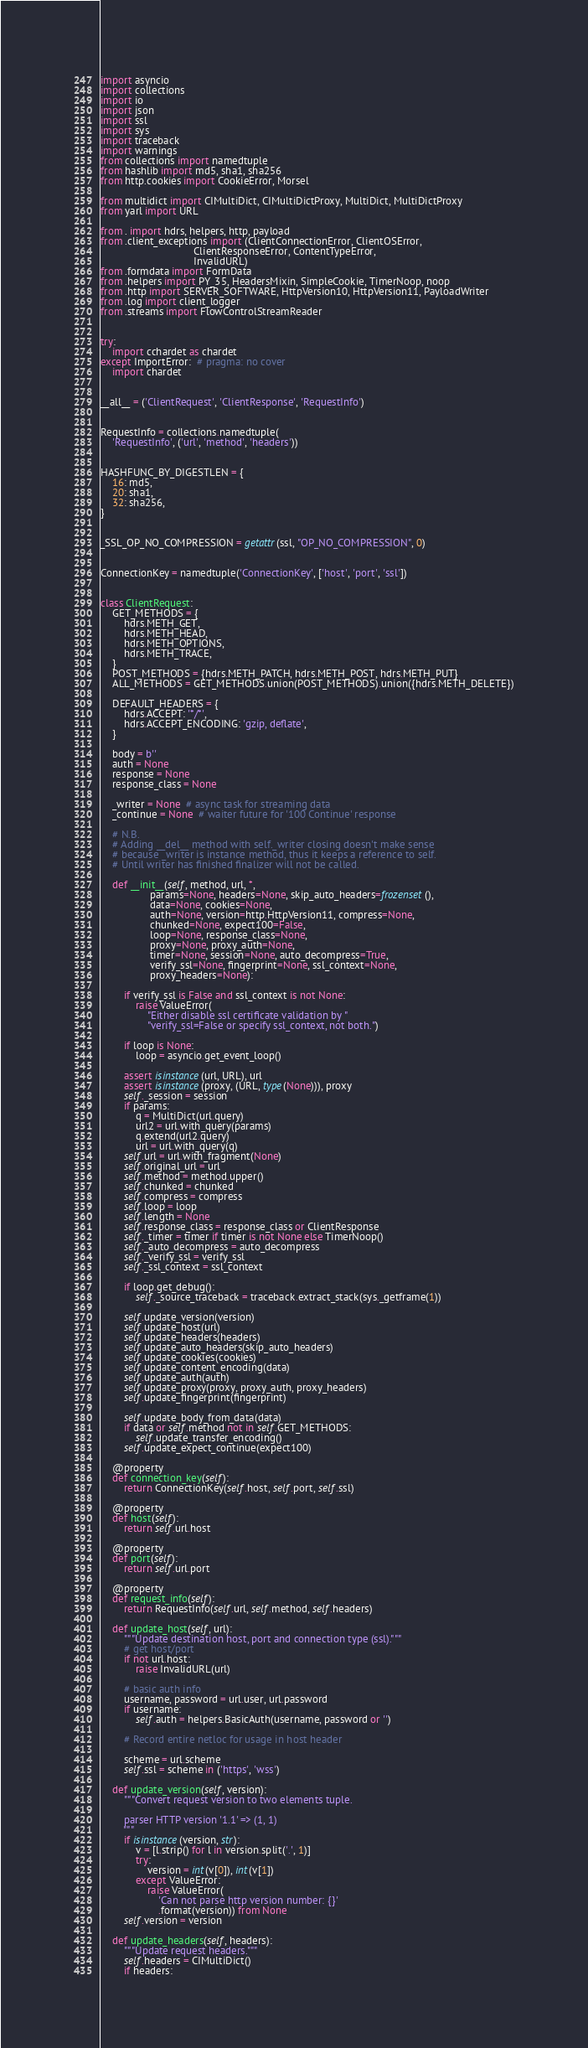Convert code to text. <code><loc_0><loc_0><loc_500><loc_500><_Python_>import asyncio
import collections
import io
import json
import ssl
import sys
import traceback
import warnings
from collections import namedtuple
from hashlib import md5, sha1, sha256
from http.cookies import CookieError, Morsel

from multidict import CIMultiDict, CIMultiDictProxy, MultiDict, MultiDictProxy
from yarl import URL

from . import hdrs, helpers, http, payload
from .client_exceptions import (ClientConnectionError, ClientOSError,
                                ClientResponseError, ContentTypeError,
                                InvalidURL)
from .formdata import FormData
from .helpers import PY_35, HeadersMixin, SimpleCookie, TimerNoop, noop
from .http import SERVER_SOFTWARE, HttpVersion10, HttpVersion11, PayloadWriter
from .log import client_logger
from .streams import FlowControlStreamReader


try:
    import cchardet as chardet
except ImportError:  # pragma: no cover
    import chardet


__all__ = ('ClientRequest', 'ClientResponse', 'RequestInfo')


RequestInfo = collections.namedtuple(
    'RequestInfo', ('url', 'method', 'headers'))


HASHFUNC_BY_DIGESTLEN = {
    16: md5,
    20: sha1,
    32: sha256,
}


_SSL_OP_NO_COMPRESSION = getattr(ssl, "OP_NO_COMPRESSION", 0)


ConnectionKey = namedtuple('ConnectionKey', ['host', 'port', 'ssl'])


class ClientRequest:
    GET_METHODS = {
        hdrs.METH_GET,
        hdrs.METH_HEAD,
        hdrs.METH_OPTIONS,
        hdrs.METH_TRACE,
    }
    POST_METHODS = {hdrs.METH_PATCH, hdrs.METH_POST, hdrs.METH_PUT}
    ALL_METHODS = GET_METHODS.union(POST_METHODS).union({hdrs.METH_DELETE})

    DEFAULT_HEADERS = {
        hdrs.ACCEPT: '*/*',
        hdrs.ACCEPT_ENCODING: 'gzip, deflate',
    }

    body = b''
    auth = None
    response = None
    response_class = None

    _writer = None  # async task for streaming data
    _continue = None  # waiter future for '100 Continue' response

    # N.B.
    # Adding __del__ method with self._writer closing doesn't make sense
    # because _writer is instance method, thus it keeps a reference to self.
    # Until writer has finished finalizer will not be called.

    def __init__(self, method, url, *,
                 params=None, headers=None, skip_auto_headers=frozenset(),
                 data=None, cookies=None,
                 auth=None, version=http.HttpVersion11, compress=None,
                 chunked=None, expect100=False,
                 loop=None, response_class=None,
                 proxy=None, proxy_auth=None,
                 timer=None, session=None, auto_decompress=True,
                 verify_ssl=None, fingerprint=None, ssl_context=None,
                 proxy_headers=None):

        if verify_ssl is False and ssl_context is not None:
            raise ValueError(
                "Either disable ssl certificate validation by "
                "verify_ssl=False or specify ssl_context, not both.")

        if loop is None:
            loop = asyncio.get_event_loop()

        assert isinstance(url, URL), url
        assert isinstance(proxy, (URL, type(None))), proxy
        self._session = session
        if params:
            q = MultiDict(url.query)
            url2 = url.with_query(params)
            q.extend(url2.query)
            url = url.with_query(q)
        self.url = url.with_fragment(None)
        self.original_url = url
        self.method = method.upper()
        self.chunked = chunked
        self.compress = compress
        self.loop = loop
        self.length = None
        self.response_class = response_class or ClientResponse
        self._timer = timer if timer is not None else TimerNoop()
        self._auto_decompress = auto_decompress
        self._verify_ssl = verify_ssl
        self._ssl_context = ssl_context

        if loop.get_debug():
            self._source_traceback = traceback.extract_stack(sys._getframe(1))

        self.update_version(version)
        self.update_host(url)
        self.update_headers(headers)
        self.update_auto_headers(skip_auto_headers)
        self.update_cookies(cookies)
        self.update_content_encoding(data)
        self.update_auth(auth)
        self.update_proxy(proxy, proxy_auth, proxy_headers)
        self.update_fingerprint(fingerprint)

        self.update_body_from_data(data)
        if data or self.method not in self.GET_METHODS:
            self.update_transfer_encoding()
        self.update_expect_continue(expect100)

    @property
    def connection_key(self):
        return ConnectionKey(self.host, self.port, self.ssl)

    @property
    def host(self):
        return self.url.host

    @property
    def port(self):
        return self.url.port

    @property
    def request_info(self):
        return RequestInfo(self.url, self.method, self.headers)

    def update_host(self, url):
        """Update destination host, port and connection type (ssl)."""
        # get host/port
        if not url.host:
            raise InvalidURL(url)

        # basic auth info
        username, password = url.user, url.password
        if username:
            self.auth = helpers.BasicAuth(username, password or '')

        # Record entire netloc for usage in host header

        scheme = url.scheme
        self.ssl = scheme in ('https', 'wss')

    def update_version(self, version):
        """Convert request version to two elements tuple.

        parser HTTP version '1.1' => (1, 1)
        """
        if isinstance(version, str):
            v = [l.strip() for l in version.split('.', 1)]
            try:
                version = int(v[0]), int(v[1])
            except ValueError:
                raise ValueError(
                    'Can not parse http version number: {}'
                    .format(version)) from None
        self.version = version

    def update_headers(self, headers):
        """Update request headers."""
        self.headers = CIMultiDict()
        if headers:</code> 